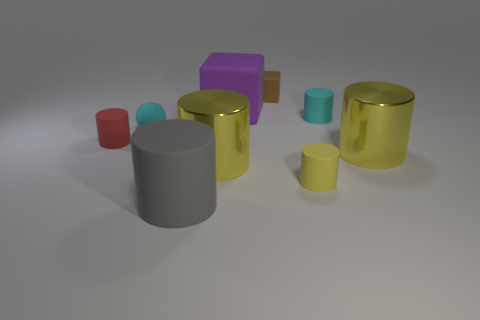Subtract all purple blocks. How many yellow cylinders are left? 3 Subtract all gray cylinders. How many cylinders are left? 5 Subtract all small yellow matte cylinders. How many cylinders are left? 5 Subtract all red cylinders. Subtract all purple blocks. How many cylinders are left? 5 Add 1 red rubber balls. How many objects exist? 10 Subtract all balls. How many objects are left? 8 Subtract 0 brown balls. How many objects are left? 9 Subtract all big gray matte cylinders. Subtract all yellow matte cylinders. How many objects are left? 7 Add 6 small red objects. How many small red objects are left? 7 Add 1 purple blocks. How many purple blocks exist? 2 